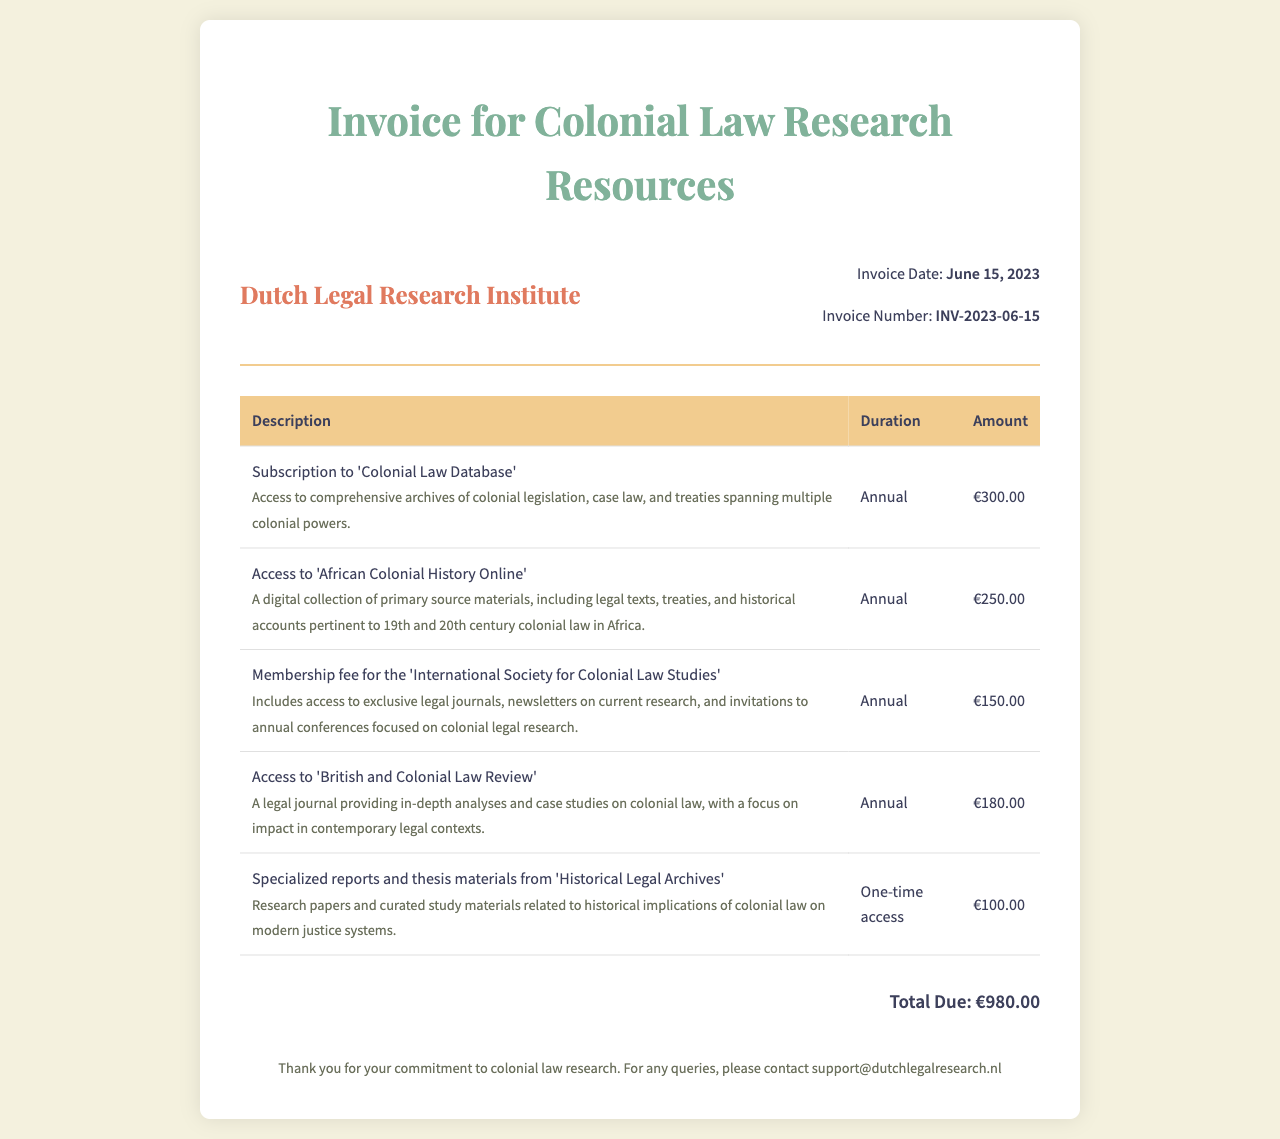What is the invoice date? The invoice date is explicitly stated in the document, which is "June 15, 2023".
Answer: June 15, 2023 What is the total due amount? The total due amount is clearly listed at the end of the invoice as "€980.00".
Answer: €980.00 How many subscriptions are listed in the invoice? The invoice provides a detailed list of subscriptions for resources, specifically a total of five subscriptions.
Answer: 5 What is the membership fee for the 'International Society for Colonial Law Studies'? This specific fee is mentioned directly in the invoice under the corresponding item, which is "€150.00".
Answer: €150.00 What type of access is the last item in the invoice? The last item is described as "One-time access," as indicated in the document.
Answer: One-time access Which resource offers digital primary source materials about legal texts in Africa? The invoice describes "Access to 'African Colonial History Online'" as the resource for primary source materials regarding legal texts in Africa.
Answer: African Colonial History Online What is the duration of the subscription to the 'Colonial Law Database'? The duration for this subscription is stated as "Annual" in the invoice.
Answer: Annual What organization is associated with the membership fee mentioned? The membership fee is associated with the "International Society for Colonial Law Studies," as mentioned in the invoice.
Answer: International Society for Colonial Law Studies What is included in the subscription to 'British and Colonial Law Review'? The subscription includes "in-depth analyses and case studies on colonial law," as described in the document.
Answer: in-depth analyses and case studies on colonial law 